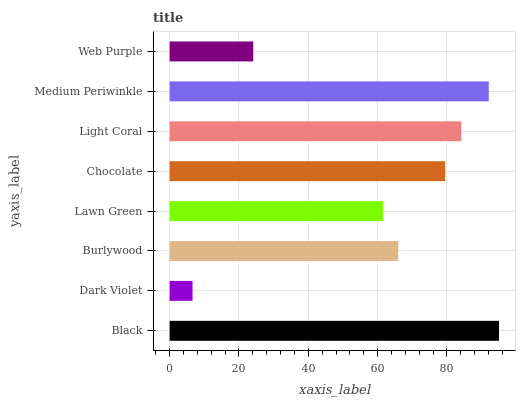Is Dark Violet the minimum?
Answer yes or no. Yes. Is Black the maximum?
Answer yes or no. Yes. Is Burlywood the minimum?
Answer yes or no. No. Is Burlywood the maximum?
Answer yes or no. No. Is Burlywood greater than Dark Violet?
Answer yes or no. Yes. Is Dark Violet less than Burlywood?
Answer yes or no. Yes. Is Dark Violet greater than Burlywood?
Answer yes or no. No. Is Burlywood less than Dark Violet?
Answer yes or no. No. Is Chocolate the high median?
Answer yes or no. Yes. Is Burlywood the low median?
Answer yes or no. Yes. Is Lawn Green the high median?
Answer yes or no. No. Is Lawn Green the low median?
Answer yes or no. No. 